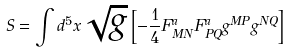Convert formula to latex. <formula><loc_0><loc_0><loc_500><loc_500>S = \int d ^ { 5 } x \sqrt { g } \left [ - \frac { 1 } { 4 } F _ { M N } ^ { a } F _ { P Q } ^ { a } g ^ { M P } g ^ { N Q } \right ]</formula> 